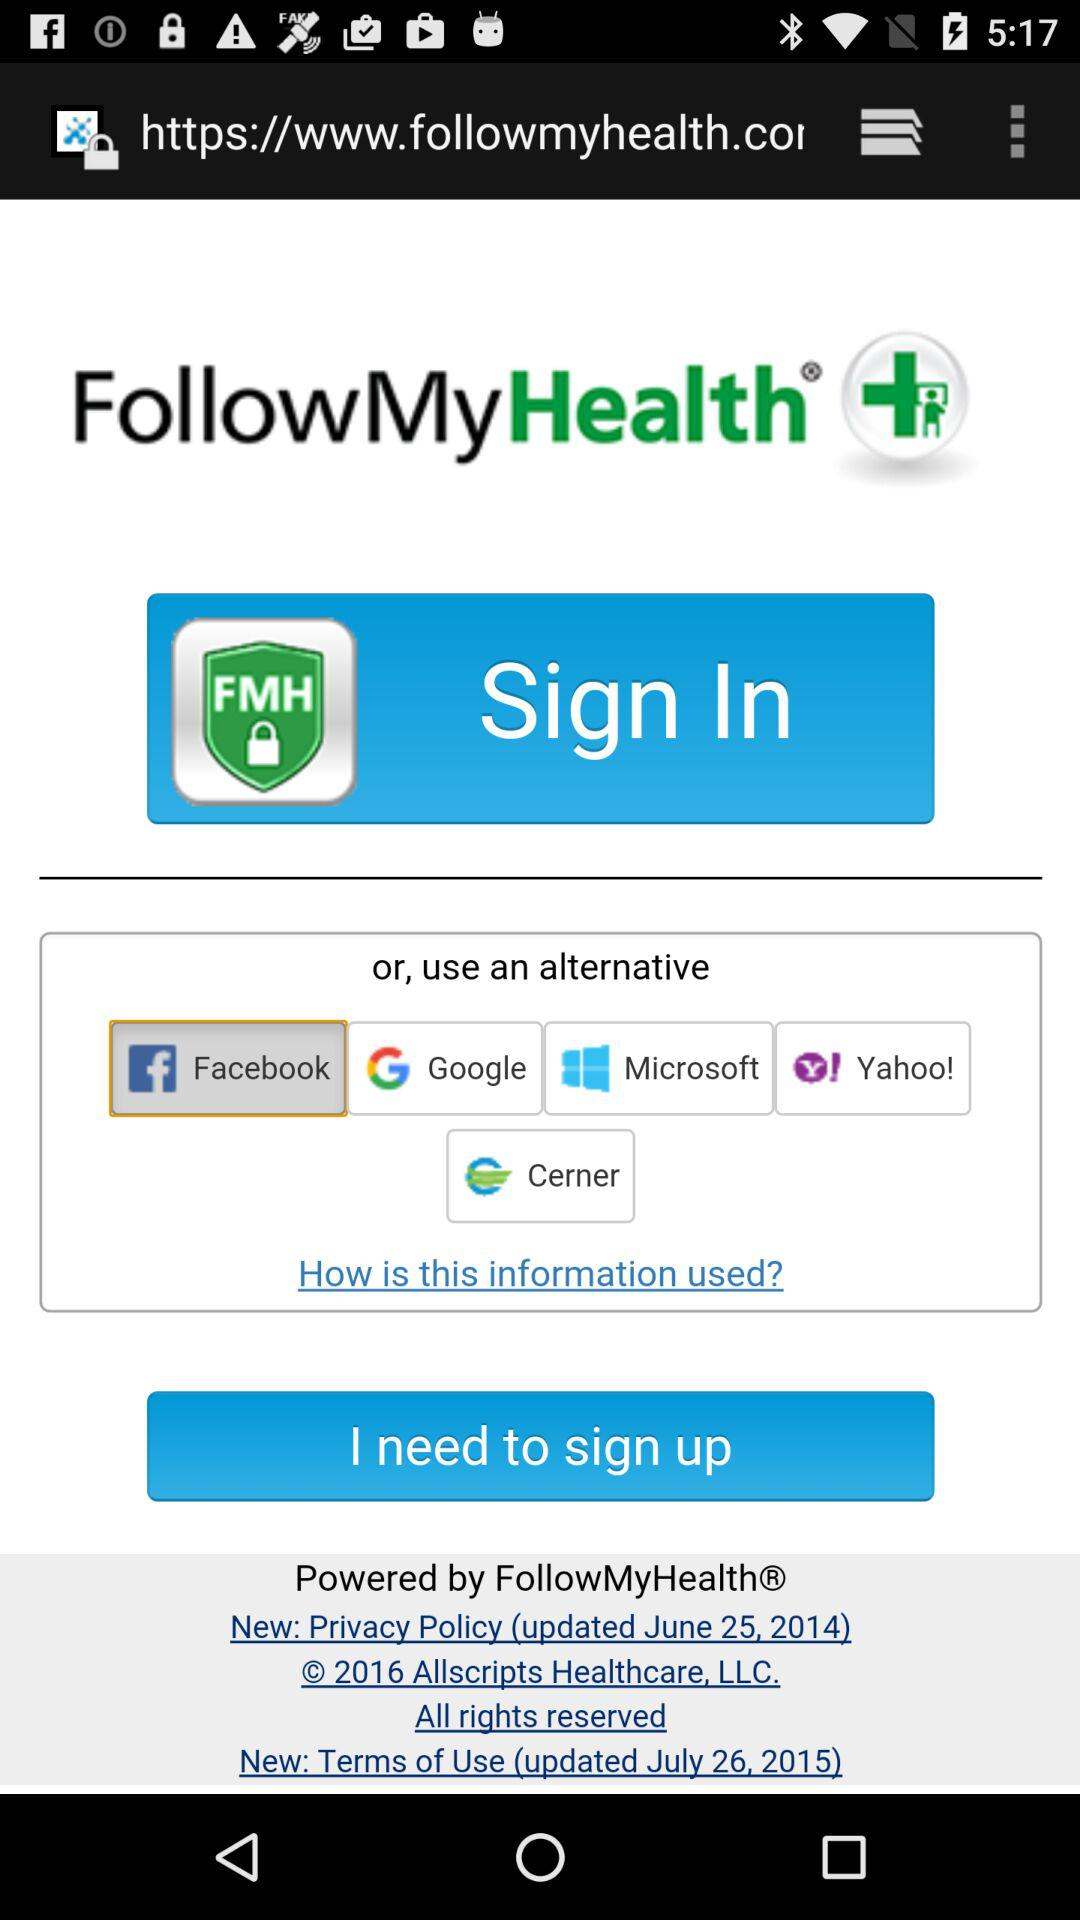Which applications can we use to sign in? The applications are "FollowMyHealth", "Facebook", "Google", "Microsoft", "Yahoo!" and "Cerner". 